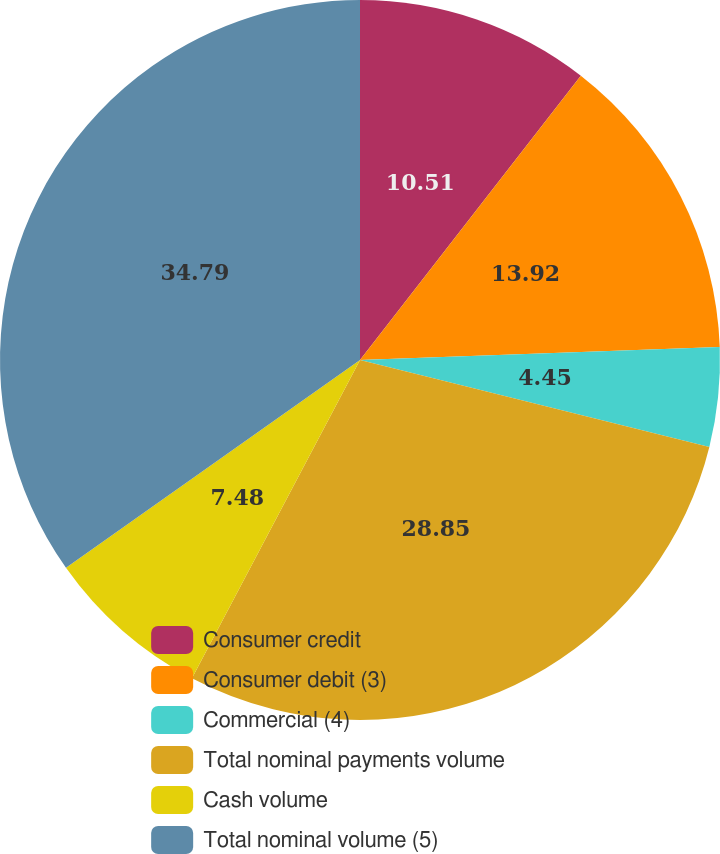Convert chart. <chart><loc_0><loc_0><loc_500><loc_500><pie_chart><fcel>Consumer credit<fcel>Consumer debit (3)<fcel>Commercial (4)<fcel>Total nominal payments volume<fcel>Cash volume<fcel>Total nominal volume (5)<nl><fcel>10.51%<fcel>13.92%<fcel>4.45%<fcel>28.85%<fcel>7.48%<fcel>34.79%<nl></chart> 